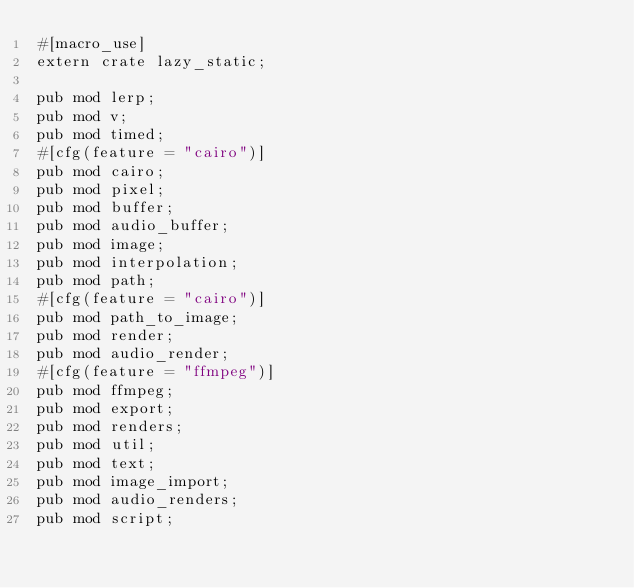<code> <loc_0><loc_0><loc_500><loc_500><_Rust_>#[macro_use]
extern crate lazy_static;

pub mod lerp;
pub mod v;
pub mod timed;
#[cfg(feature = "cairo")]
pub mod cairo;
pub mod pixel;
pub mod buffer;
pub mod audio_buffer;
pub mod image;
pub mod interpolation;
pub mod path;
#[cfg(feature = "cairo")]
pub mod path_to_image;
pub mod render;
pub mod audio_render;
#[cfg(feature = "ffmpeg")]
pub mod ffmpeg;
pub mod export;
pub mod renders;
pub mod util;
pub mod text;
pub mod image_import;
pub mod audio_renders;
pub mod script;
</code> 